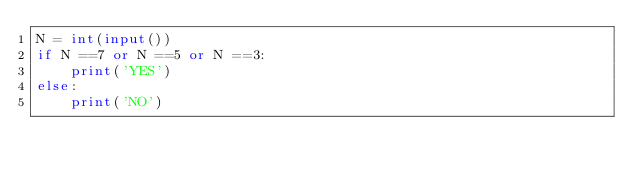Convert code to text. <code><loc_0><loc_0><loc_500><loc_500><_Python_>N = int(input())
if N ==7 or N ==5 or N ==3:
    print('YES')
else:
    print('NO') </code> 